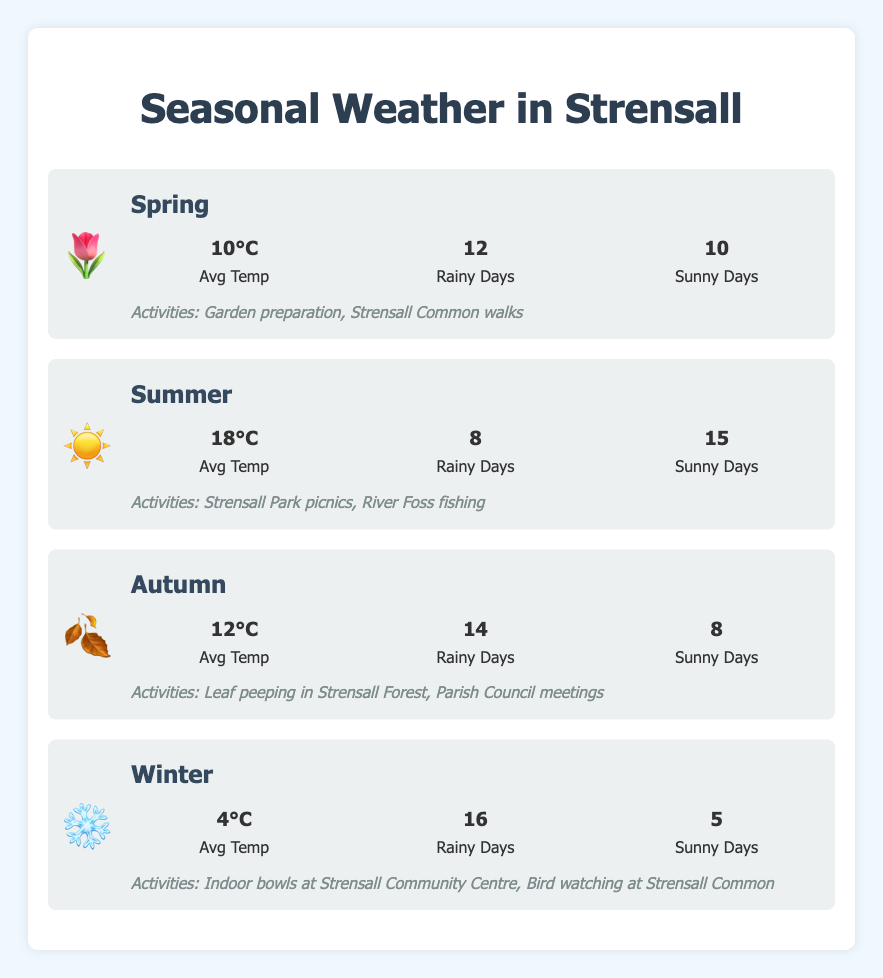What's the average temperature in Summer? To find the average temperature in Summer, we simply look under the Summer section for the value next to "Avg Temp," which is written as 18°C.
Answer: 18°C Which season has the most rainy days? By comparing the values under "Rainy Days" for all seasons, we see that Winter has 16 rainy days, which is the highest.
Answer: Winter How many more sunny days are there in Summer compared to Autumn? To compare sunny days, we find the values for Summer and Autumn under "Sunny Days." Summer has 15 sunny days, and Autumn has 8, so the difference is 15 - 8.
Answer: 7 In which season does the highest average temperature occur, and what activities are suggested for that season? Checking the average temperatures under each season, Summer has the highest with 18°C. The suggested activities for Summer are Strensall Park picnics and River Foss fishing.
Answer: Summer, Strensall Park picnics and River Foss fishing What activities can you do in Spring and Winter? Look under the "activities" listed for Spring and Winter. For Spring, the activities are Garden preparation and Strensall Common walks. For Winter, they are Indoor bowls at Strensall Community Centre and Bird watching at Strensall Common.
Answer: Garden preparation, Strensall Common walks, Indoor bowls at Strensall Community Centre, Bird watching at Strensall Common Comparing sunny days, does Spring or Winter have more? Spring has 10 sunny days, while Winter has 5 sunny days. Therefore, Spring has more sunny days.
Answer: Spring Which two seasons have a difference of 6°C in their average temperatures? By analyzing the average temperatures for all seasons, Summer has 18°C and Spring has 10°C. The difference between these two is 18 - 10, which equals 8°C. For 6°C, check between Summer and Autumn (18 - 12) or Spring and Winter (10 - 4), both equal 6°C.
Answer: Spring and Winter List the seasons in order of increasing average temperature. The average temperatures are Spring (10°C), Summer (18°C), Autumn (12°C), and Winter (4°C). Ordering them from lowest to highest is Winter (4°C), Spring (10°C), Autumn (12°C), Summer (18°C).
Answer: Winter, Spring, Autumn, Summer If I want to avoid rainy days, which season should I choose? To avoid rainy days, we should select the season with the least rainy days. Summer has the fewest with 8 rainy days.
Answer: Summer What is the combined number of rainy and sunny days in Autumn? To find the combined total, add the number of rainy and sunny days in Autumn: 14 (rainy) + 8 (sunny) = 22 days.
Answer: 22 